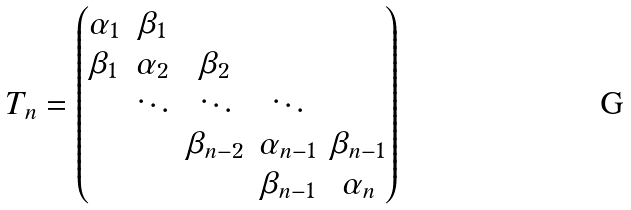<formula> <loc_0><loc_0><loc_500><loc_500>T _ { n } = \begin{pmatrix} \alpha _ { 1 } & \beta _ { 1 } & & & \\ \beta _ { 1 } & \alpha _ { 2 } & \beta _ { 2 } & & \\ & \ddots & \ddots & \ddots & \\ & & \beta _ { n - 2 } & \alpha _ { n - 1 } & \beta _ { n - 1 } \\ & & & \beta _ { n - 1 } & \alpha _ { n } \end{pmatrix}</formula> 